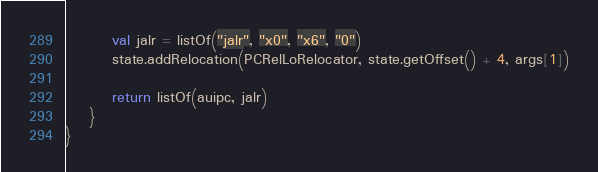Convert code to text. <code><loc_0><loc_0><loc_500><loc_500><_Kotlin_>
        val jalr = listOf("jalr", "x0", "x6", "0")
        state.addRelocation(PCRelLoRelocator, state.getOffset() + 4, args[1])

        return listOf(auipc, jalr)
    }
}
</code> 